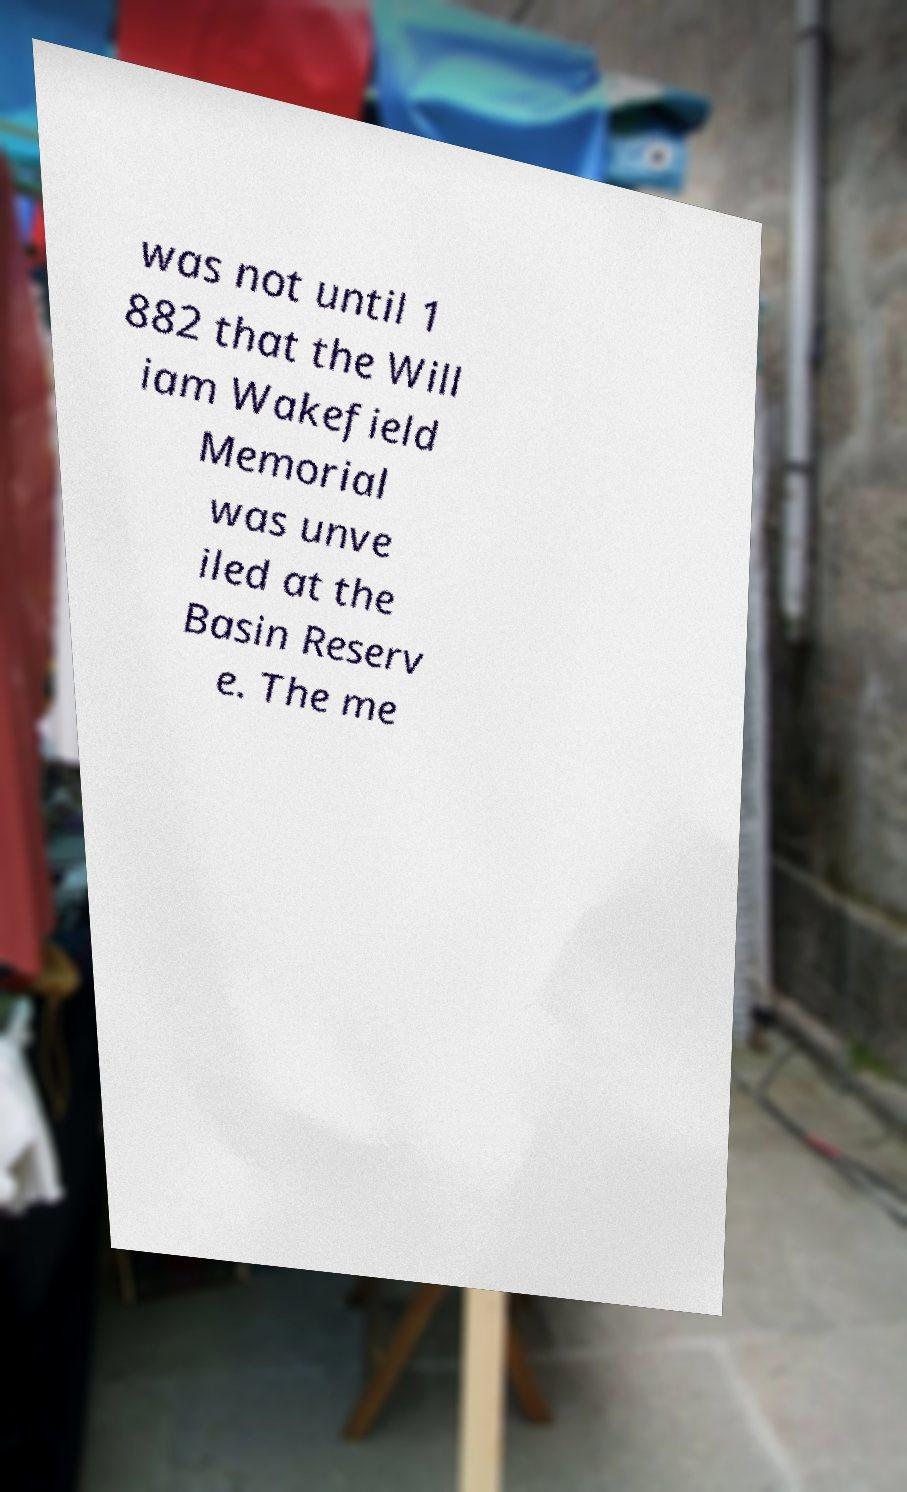Could you assist in decoding the text presented in this image and type it out clearly? was not until 1 882 that the Will iam Wakefield Memorial was unve iled at the Basin Reserv e. The me 